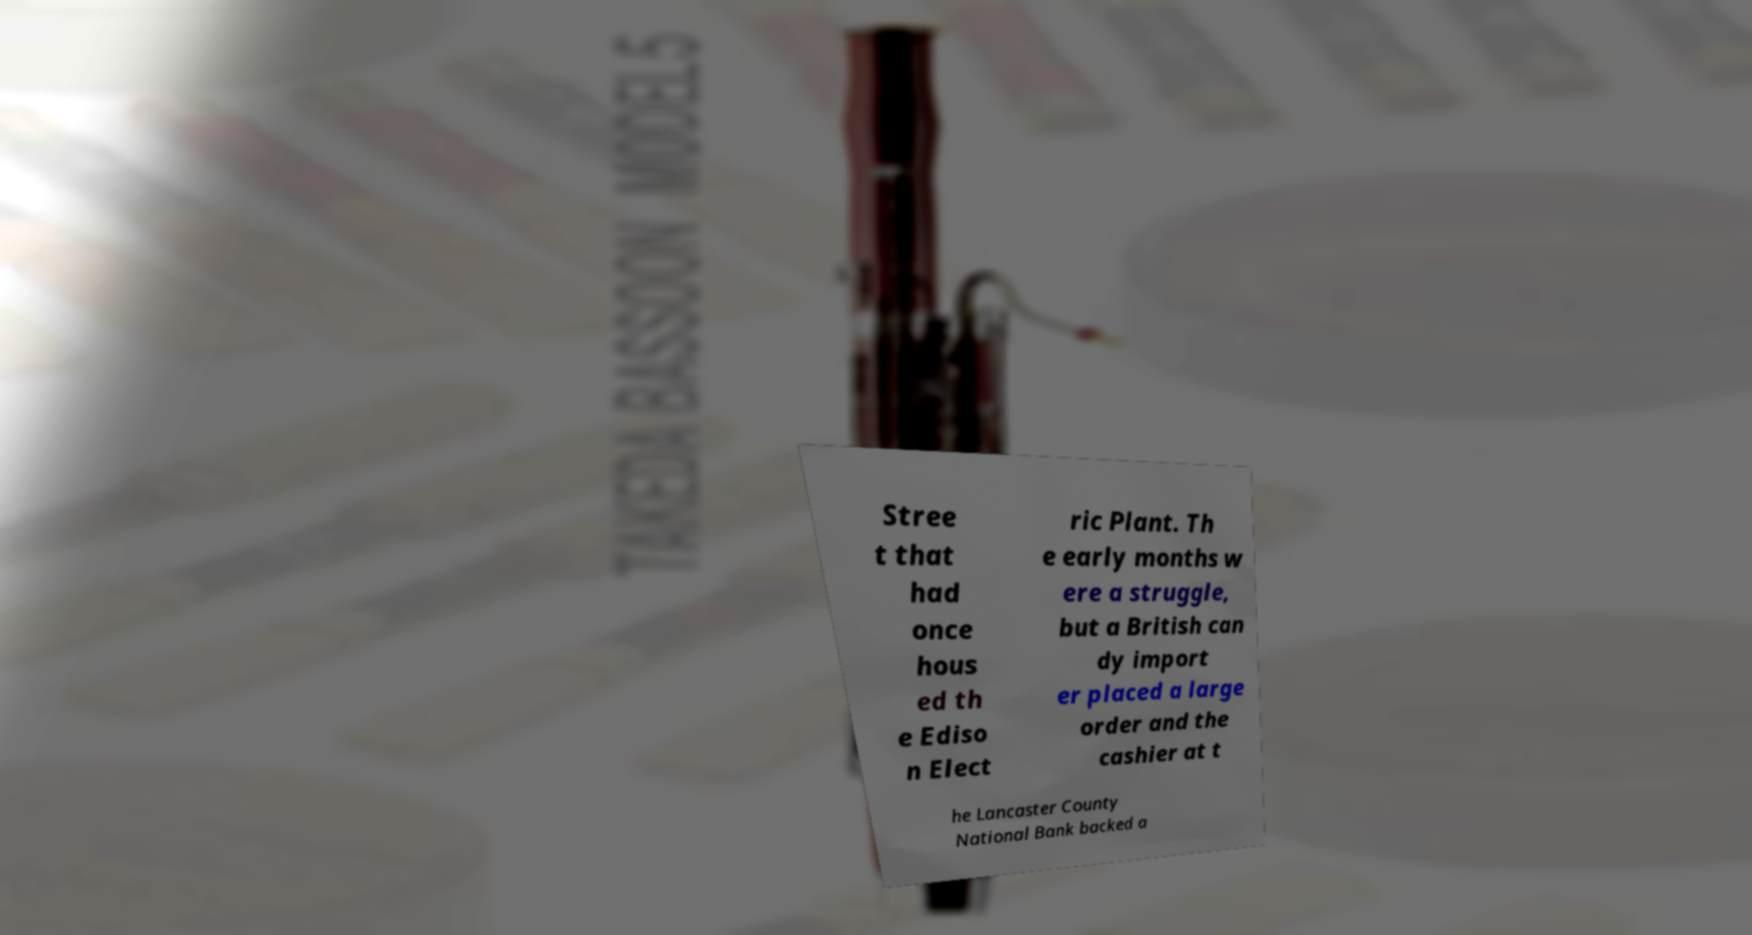I need the written content from this picture converted into text. Can you do that? Stree t that had once hous ed th e Ediso n Elect ric Plant. Th e early months w ere a struggle, but a British can dy import er placed a large order and the cashier at t he Lancaster County National Bank backed a 